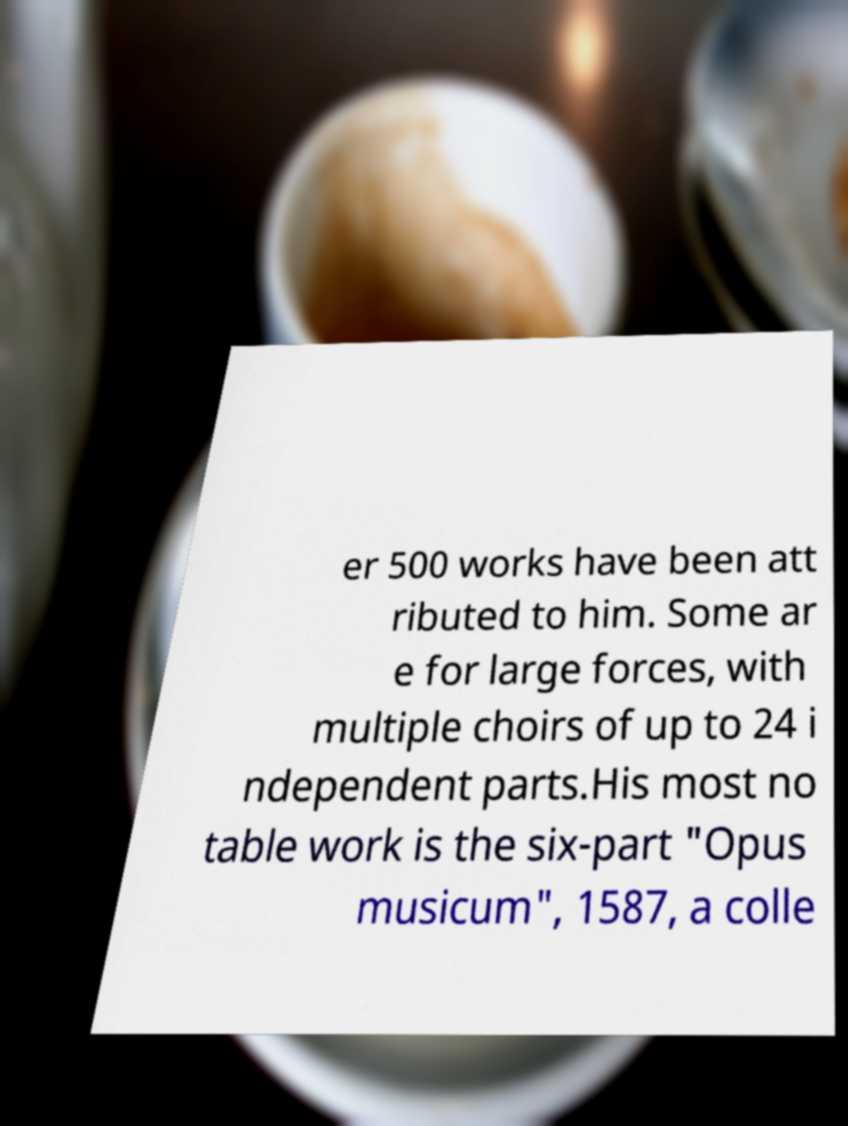I need the written content from this picture converted into text. Can you do that? er 500 works have been att ributed to him. Some ar e for large forces, with multiple choirs of up to 24 i ndependent parts.His most no table work is the six-part "Opus musicum", 1587, a colle 